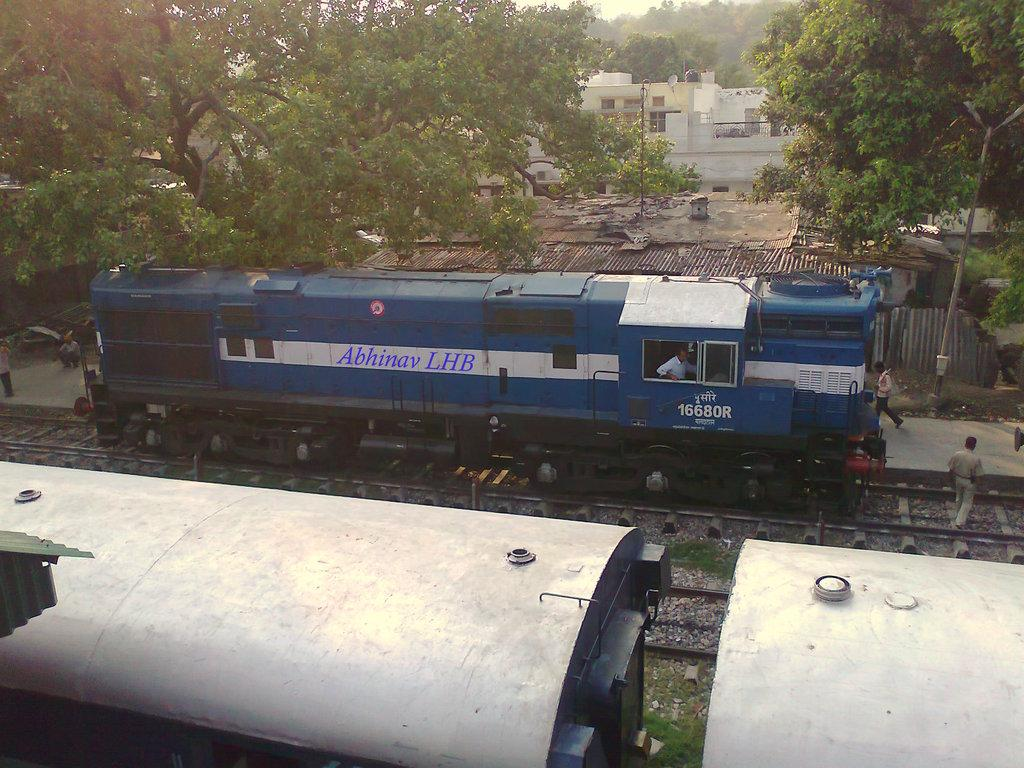What type of vehicles can be seen on the railway track in the image? There are trains on the railway track in the image. What are the people in the image doing? The people in the image are walking on a path. What can be seen in the background of the image? There are buildings, trees, and the sky visible in the background of the image. Where is the pail located in the image? There is no pail present in the image. What type of health services are available in the image? The image does not depict any health services or facilities. 